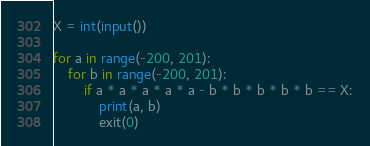<code> <loc_0><loc_0><loc_500><loc_500><_Python_>X = int(input())

for a in range(-200, 201):
    for b in range(-200, 201):
        if a * a * a * a * a - b * b * b * b * b == X:
            print(a, b)
            exit(0)</code> 